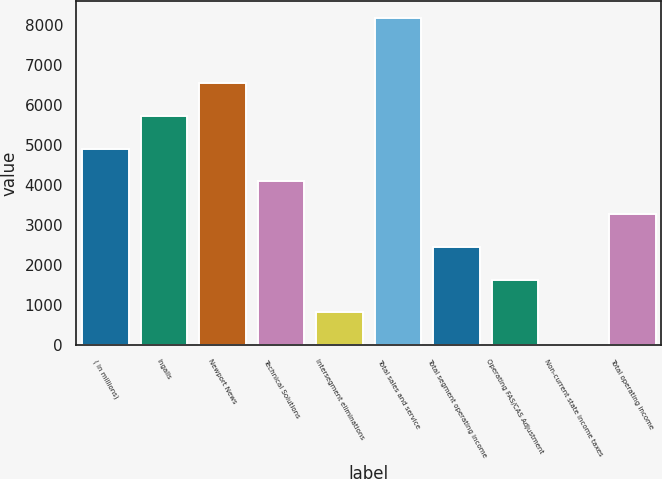Convert chart. <chart><loc_0><loc_0><loc_500><loc_500><bar_chart><fcel>( in millions)<fcel>Ingalls<fcel>Newport News<fcel>Technical Solutions<fcel>Intersegment eliminations<fcel>Total sales and service<fcel>Total segment operating income<fcel>Operating FAS/CAS Adjustment<fcel>Non-current state income taxes<fcel>Total operating income<nl><fcel>4906.4<fcel>5723.8<fcel>6541.2<fcel>4089<fcel>819.4<fcel>8176<fcel>2454.2<fcel>1636.8<fcel>2<fcel>3271.6<nl></chart> 